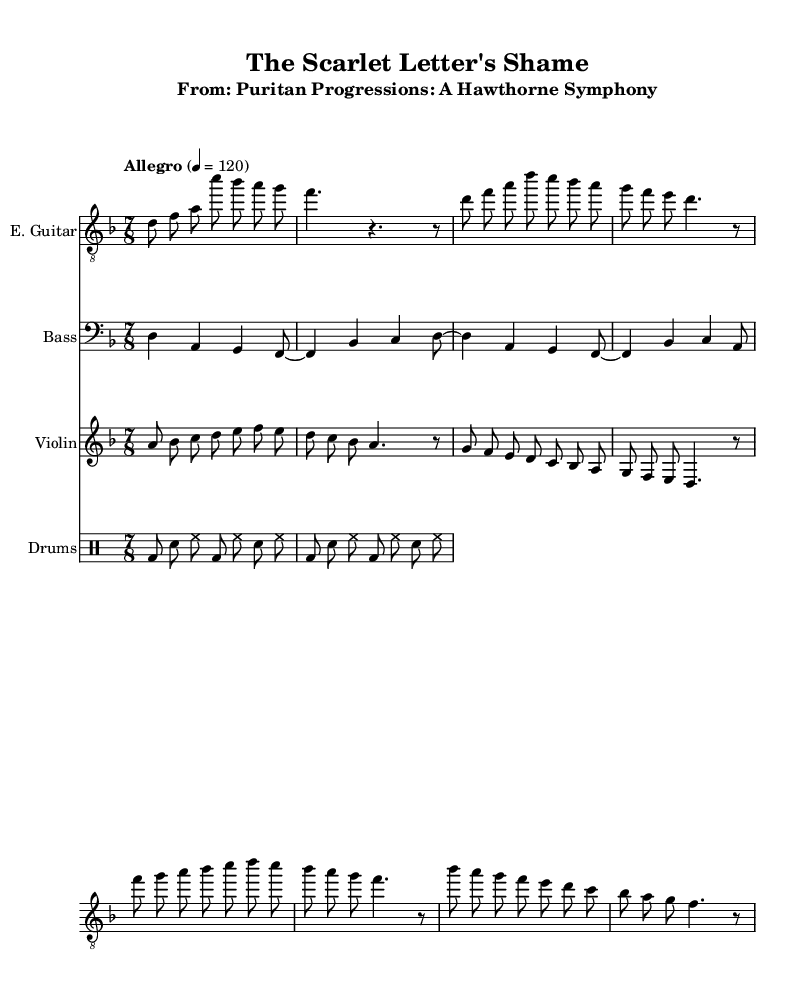What is the key signature of this music? The key signature is D minor, which has one flat (B-flat). This is indicated in the global section of the code where `\key d \minor` is specified.
Answer: D minor What is the time signature of this piece? The time signature is 7/8, which is found in the global section of the code with `\time 7/8`. This indicates that there are seven eighth-note beats per measure.
Answer: 7/8 What is the tempo marking of the piece? The tempo marking is "Allegro" and is set at 120 beats per minute, as indicated in the global section of the code where `\tempo "Allegro" 4 = 120` appears.
Answer: Allegro, 120 What instrument plays the counter-melody during the chorus? The counter-melody during the chorus is played by the violin. This is evident in the section where the violin part is outlined, specifically for the chorus melody lines.
Answer: Violin How many measures are in the Verse section of the electric guitar part? There are four measures in the Verse section as shown in the electric guitar notation, where each segment of the music is divided into measurable counts. The structure confirms the measure count distinctly.
Answer: 4 What type of rhythmic pattern is used in the drum section? The drum section uses a basic rock rhythmic pattern consisting of bass drum, snare, and hi-hat, as detailed in the drumPattern section with alternating hits.
Answer: Rock pattern How does the bass guitar line relate to the chord progression? The bass guitar line follows a simplified version of the chord progression given in the electric guitar part, ensuring it complements the harmonic structure throughout the piece. This is evident from the matching rhythmic figures and notes.
Answer: Simplified progression 